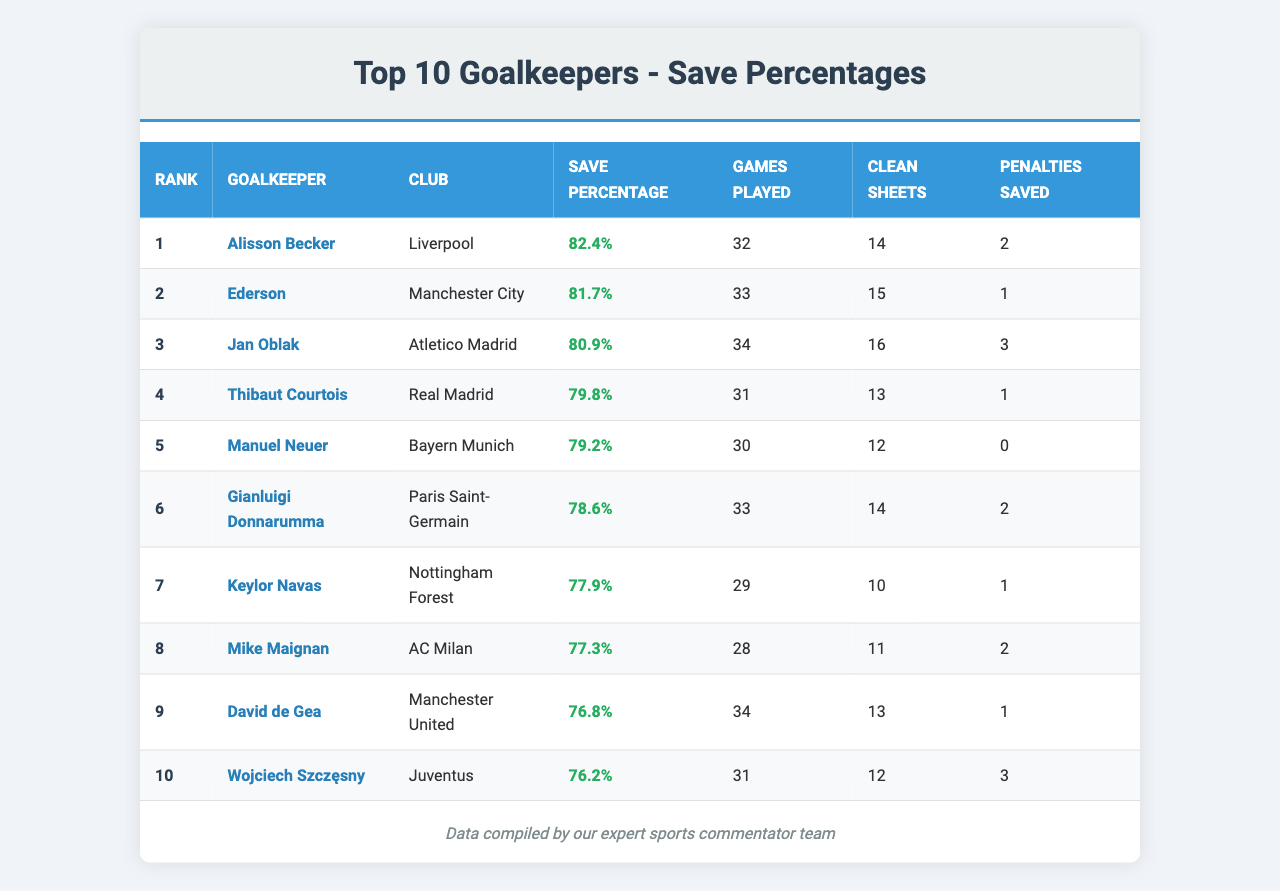What is the save percentage of Alisson Becker? The save percentage for Alisson Becker is explicitly listed in the table, showing he has a save percentage of 82.4%.
Answer: 82.4% Who has the highest number of clean sheets, and how many? The table shows that Jan Oblak has the highest number of clean sheets, with a total of 16.
Answer: Jan Oblak, 16 How many games did Manuel Neuer play? The table indicates that Manuel Neuer played 30 games this season.
Answer: 30 Which goalkeeper has the lowest save percentage in this top ten list? By reviewing the save percentages in the table, Wojciech Szczęsny has the lowest save percentage at 76.2%.
Answer: Wojciech Szczęsny What is the average save percentage of the top three goalkeepers? To calculate the average, we take the save percentages of the top three goalkeepers (82.4%, 81.7%, 80.9%), sum them (82.4 + 81.7 + 80.9 = 245.0), and divide by 3, resulting in an average of 81.67%.
Answer: 81.67% Is it true that Ederson saved more penalties than Alisson Becker? The table shows Ederson saved 1 penalty while Alisson Becker saved 2 penalties, so the statement is false.
Answer: No How many total clean sheets did the top five goalkeepers achieve? By summing the clean sheets of the top five goalkeepers (14 + 15 + 16 + 13 + 12 = 70), we find the total is 70 clean sheets.
Answer: 70 Which goalkeeper has played the most games, and what is their save percentage? Ederson has played the most games, 33, and his save percentage is 81.7%.
Answer: Ederson, 81.7% If we consider the top ten goalkeepers, how many of them have saved at least two penalties? Looking at the table, three goalkeepers (Alisson Becker, Gianluigi Donnarumma, and Wojciech Szczęsny) have saved at least two penalties.
Answer: 3 What is the difference in save percentage between the first and tenth goalkeeper? The difference can be calculated by subtracting the save percentage of Wojciech Szczęsny (76.2%) from Alisson Becker (82.4%). The difference is 82.4% - 76.2% = 6.2%.
Answer: 6.2% 